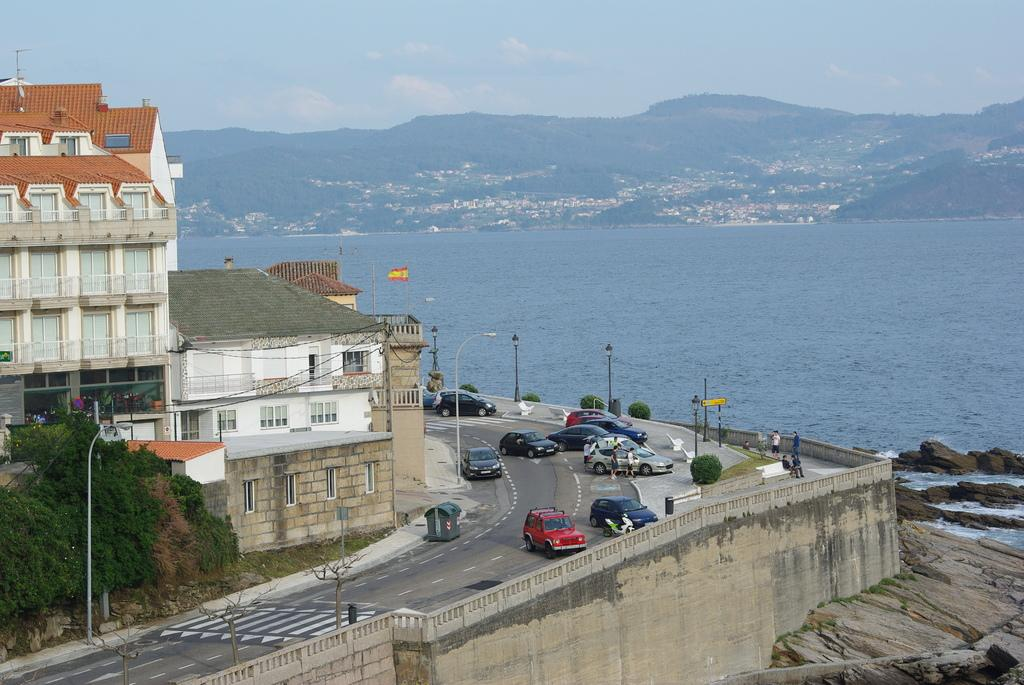What can be seen on the roads in the image? There are vehicles and people on the roads in the image. What is located in the left corner of the image? There are buildings in the left corner of the image. What can be seen in the background of the image? Water and mountains are visible in the background of the image. Can you tell me what the grandmother is cooking for dinner in the image? There is no grandmother or dinner present in the image. What type of person is visible in the image? The question is too vague, as there are multiple people visible in the image. Please specify which person you are referring to. 